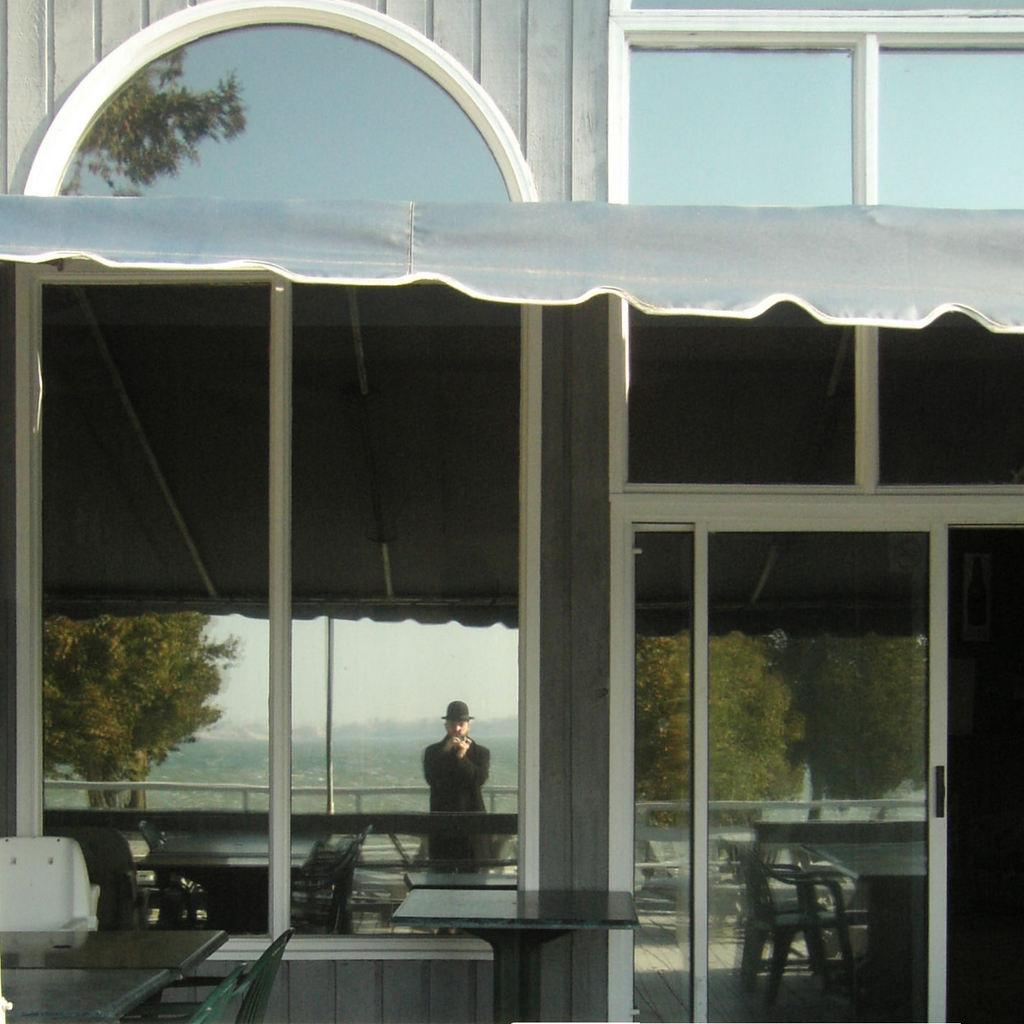What type of furniture is present in the image? There are tables and chairs in the image. What can be seen in the background of the image? There are trees in the image. Is there a person visible in the image? Yes, there is a person standing in the image. What is the person wearing on their head? The person is wearing a black hat. What is the person wearing on their body? The person is wearing a black dress. Can you see a giraffe in the image? No, there is no giraffe present in the image. Is there a baseball game happening in the image? No, there is no reference to a baseball game or any sports activity in the image. 